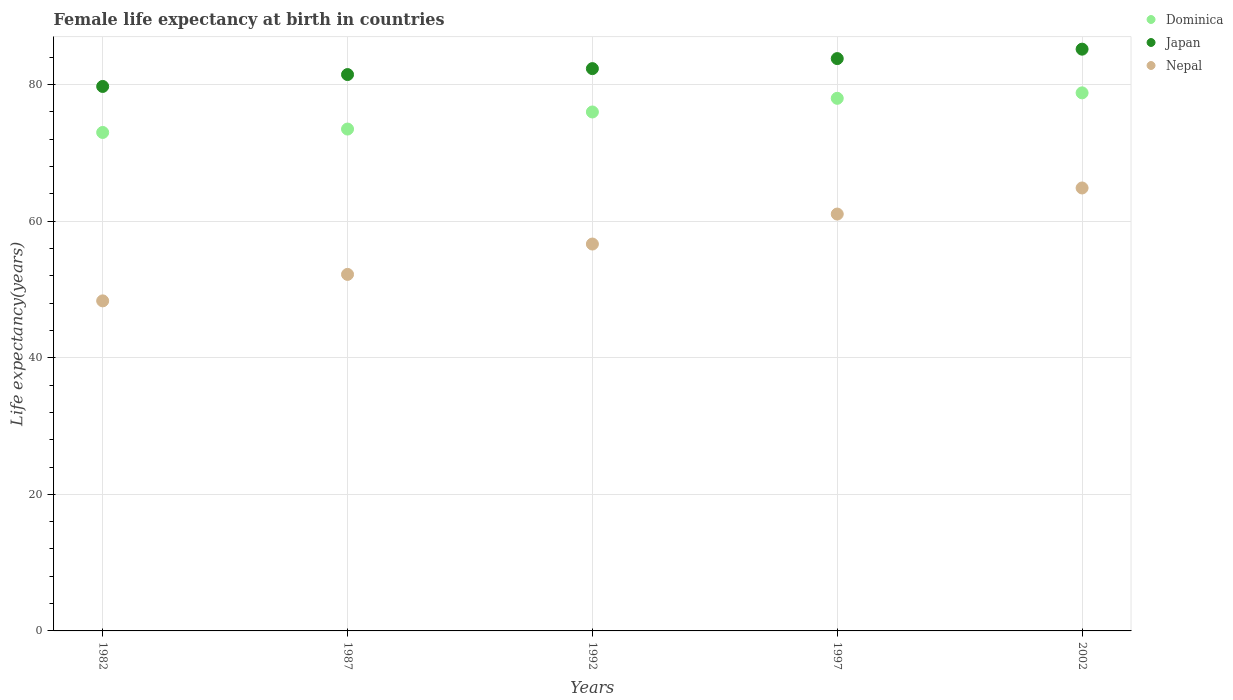Is the number of dotlines equal to the number of legend labels?
Offer a very short reply. Yes. What is the female life expectancy at birth in Japan in 1997?
Make the answer very short. 83.82. Across all years, what is the maximum female life expectancy at birth in Japan?
Your answer should be very brief. 85.2. Across all years, what is the minimum female life expectancy at birth in Nepal?
Make the answer very short. 48.34. What is the total female life expectancy at birth in Nepal in the graph?
Provide a short and direct response. 283.13. What is the difference between the female life expectancy at birth in Dominica in 1997 and that in 2002?
Provide a succinct answer. -0.8. What is the difference between the female life expectancy at birth in Nepal in 2002 and the female life expectancy at birth in Japan in 1982?
Offer a terse response. -14.87. What is the average female life expectancy at birth in Nepal per year?
Ensure brevity in your answer.  56.63. In the year 1992, what is the difference between the female life expectancy at birth in Nepal and female life expectancy at birth in Dominica?
Your answer should be very brief. -19.34. What is the ratio of the female life expectancy at birth in Nepal in 1982 to that in 1987?
Give a very brief answer. 0.93. Is the difference between the female life expectancy at birth in Nepal in 1987 and 1992 greater than the difference between the female life expectancy at birth in Dominica in 1987 and 1992?
Provide a short and direct response. No. What is the difference between the highest and the second highest female life expectancy at birth in Japan?
Offer a very short reply. 1.38. What is the difference between the highest and the lowest female life expectancy at birth in Nepal?
Your response must be concise. 16.53. Is it the case that in every year, the sum of the female life expectancy at birth in Dominica and female life expectancy at birth in Japan  is greater than the female life expectancy at birth in Nepal?
Your answer should be very brief. Yes. How many dotlines are there?
Keep it short and to the point. 3. What is the difference between two consecutive major ticks on the Y-axis?
Your response must be concise. 20. What is the title of the graph?
Offer a terse response. Female life expectancy at birth in countries. Does "Korea (Democratic)" appear as one of the legend labels in the graph?
Keep it short and to the point. No. What is the label or title of the X-axis?
Give a very brief answer. Years. What is the label or title of the Y-axis?
Offer a very short reply. Life expectancy(years). What is the Life expectancy(years) of Japan in 1982?
Your answer should be very brief. 79.74. What is the Life expectancy(years) of Nepal in 1982?
Provide a short and direct response. 48.34. What is the Life expectancy(years) in Dominica in 1987?
Give a very brief answer. 73.5. What is the Life expectancy(years) of Japan in 1987?
Your response must be concise. 81.48. What is the Life expectancy(years) of Nepal in 1987?
Your answer should be very brief. 52.22. What is the Life expectancy(years) in Dominica in 1992?
Offer a terse response. 76. What is the Life expectancy(years) in Japan in 1992?
Your answer should be compact. 82.35. What is the Life expectancy(years) in Nepal in 1992?
Keep it short and to the point. 56.66. What is the Life expectancy(years) in Japan in 1997?
Make the answer very short. 83.82. What is the Life expectancy(years) in Nepal in 1997?
Your answer should be compact. 61.05. What is the Life expectancy(years) of Dominica in 2002?
Offer a terse response. 78.8. What is the Life expectancy(years) of Japan in 2002?
Keep it short and to the point. 85.2. What is the Life expectancy(years) in Nepal in 2002?
Offer a terse response. 64.87. Across all years, what is the maximum Life expectancy(years) in Dominica?
Offer a very short reply. 78.8. Across all years, what is the maximum Life expectancy(years) in Japan?
Provide a succinct answer. 85.2. Across all years, what is the maximum Life expectancy(years) of Nepal?
Give a very brief answer. 64.87. Across all years, what is the minimum Life expectancy(years) in Japan?
Provide a succinct answer. 79.74. Across all years, what is the minimum Life expectancy(years) in Nepal?
Your response must be concise. 48.34. What is the total Life expectancy(years) of Dominica in the graph?
Provide a succinct answer. 379.3. What is the total Life expectancy(years) in Japan in the graph?
Ensure brevity in your answer.  412.59. What is the total Life expectancy(years) of Nepal in the graph?
Provide a short and direct response. 283.13. What is the difference between the Life expectancy(years) in Japan in 1982 and that in 1987?
Keep it short and to the point. -1.74. What is the difference between the Life expectancy(years) of Nepal in 1982 and that in 1987?
Keep it short and to the point. -3.88. What is the difference between the Life expectancy(years) of Dominica in 1982 and that in 1992?
Keep it short and to the point. -3. What is the difference between the Life expectancy(years) of Japan in 1982 and that in 1992?
Your response must be concise. -2.61. What is the difference between the Life expectancy(years) in Nepal in 1982 and that in 1992?
Make the answer very short. -8.32. What is the difference between the Life expectancy(years) in Dominica in 1982 and that in 1997?
Provide a succinct answer. -5. What is the difference between the Life expectancy(years) of Japan in 1982 and that in 1997?
Your answer should be very brief. -4.08. What is the difference between the Life expectancy(years) in Nepal in 1982 and that in 1997?
Offer a very short reply. -12.71. What is the difference between the Life expectancy(years) in Japan in 1982 and that in 2002?
Offer a terse response. -5.46. What is the difference between the Life expectancy(years) in Nepal in 1982 and that in 2002?
Your response must be concise. -16.54. What is the difference between the Life expectancy(years) in Dominica in 1987 and that in 1992?
Make the answer very short. -2.5. What is the difference between the Life expectancy(years) of Japan in 1987 and that in 1992?
Offer a very short reply. -0.87. What is the difference between the Life expectancy(years) in Nepal in 1987 and that in 1992?
Your answer should be very brief. -4.45. What is the difference between the Life expectancy(years) in Japan in 1987 and that in 1997?
Provide a short and direct response. -2.34. What is the difference between the Life expectancy(years) in Nepal in 1987 and that in 1997?
Offer a very short reply. -8.84. What is the difference between the Life expectancy(years) in Japan in 1987 and that in 2002?
Provide a short and direct response. -3.72. What is the difference between the Life expectancy(years) in Nepal in 1987 and that in 2002?
Provide a succinct answer. -12.66. What is the difference between the Life expectancy(years) in Dominica in 1992 and that in 1997?
Provide a succinct answer. -2. What is the difference between the Life expectancy(years) of Japan in 1992 and that in 1997?
Provide a short and direct response. -1.47. What is the difference between the Life expectancy(years) of Nepal in 1992 and that in 1997?
Keep it short and to the point. -4.39. What is the difference between the Life expectancy(years) of Japan in 1992 and that in 2002?
Keep it short and to the point. -2.85. What is the difference between the Life expectancy(years) of Nepal in 1992 and that in 2002?
Your answer should be very brief. -8.21. What is the difference between the Life expectancy(years) in Dominica in 1997 and that in 2002?
Offer a very short reply. -0.8. What is the difference between the Life expectancy(years) of Japan in 1997 and that in 2002?
Ensure brevity in your answer.  -1.38. What is the difference between the Life expectancy(years) of Nepal in 1997 and that in 2002?
Keep it short and to the point. -3.82. What is the difference between the Life expectancy(years) in Dominica in 1982 and the Life expectancy(years) in Japan in 1987?
Your answer should be compact. -8.48. What is the difference between the Life expectancy(years) in Dominica in 1982 and the Life expectancy(years) in Nepal in 1987?
Offer a very short reply. 20.79. What is the difference between the Life expectancy(years) in Japan in 1982 and the Life expectancy(years) in Nepal in 1987?
Your response must be concise. 27.52. What is the difference between the Life expectancy(years) of Dominica in 1982 and the Life expectancy(years) of Japan in 1992?
Provide a succinct answer. -9.35. What is the difference between the Life expectancy(years) of Dominica in 1982 and the Life expectancy(years) of Nepal in 1992?
Ensure brevity in your answer.  16.34. What is the difference between the Life expectancy(years) of Japan in 1982 and the Life expectancy(years) of Nepal in 1992?
Offer a very short reply. 23.08. What is the difference between the Life expectancy(years) of Dominica in 1982 and the Life expectancy(years) of Japan in 1997?
Offer a very short reply. -10.82. What is the difference between the Life expectancy(years) of Dominica in 1982 and the Life expectancy(years) of Nepal in 1997?
Keep it short and to the point. 11.95. What is the difference between the Life expectancy(years) of Japan in 1982 and the Life expectancy(years) of Nepal in 1997?
Offer a very short reply. 18.69. What is the difference between the Life expectancy(years) of Dominica in 1982 and the Life expectancy(years) of Nepal in 2002?
Keep it short and to the point. 8.13. What is the difference between the Life expectancy(years) in Japan in 1982 and the Life expectancy(years) in Nepal in 2002?
Your answer should be compact. 14.87. What is the difference between the Life expectancy(years) in Dominica in 1987 and the Life expectancy(years) in Japan in 1992?
Your answer should be very brief. -8.85. What is the difference between the Life expectancy(years) in Dominica in 1987 and the Life expectancy(years) in Nepal in 1992?
Offer a terse response. 16.84. What is the difference between the Life expectancy(years) of Japan in 1987 and the Life expectancy(years) of Nepal in 1992?
Offer a very short reply. 24.82. What is the difference between the Life expectancy(years) of Dominica in 1987 and the Life expectancy(years) of Japan in 1997?
Give a very brief answer. -10.32. What is the difference between the Life expectancy(years) in Dominica in 1987 and the Life expectancy(years) in Nepal in 1997?
Your answer should be very brief. 12.45. What is the difference between the Life expectancy(years) in Japan in 1987 and the Life expectancy(years) in Nepal in 1997?
Offer a very short reply. 20.43. What is the difference between the Life expectancy(years) of Dominica in 1987 and the Life expectancy(years) of Nepal in 2002?
Offer a very short reply. 8.63. What is the difference between the Life expectancy(years) in Japan in 1987 and the Life expectancy(years) in Nepal in 2002?
Keep it short and to the point. 16.61. What is the difference between the Life expectancy(years) of Dominica in 1992 and the Life expectancy(years) of Japan in 1997?
Provide a short and direct response. -7.82. What is the difference between the Life expectancy(years) of Dominica in 1992 and the Life expectancy(years) of Nepal in 1997?
Provide a succinct answer. 14.95. What is the difference between the Life expectancy(years) of Japan in 1992 and the Life expectancy(years) of Nepal in 1997?
Your answer should be very brief. 21.3. What is the difference between the Life expectancy(years) of Dominica in 1992 and the Life expectancy(years) of Nepal in 2002?
Your answer should be compact. 11.13. What is the difference between the Life expectancy(years) in Japan in 1992 and the Life expectancy(years) in Nepal in 2002?
Your response must be concise. 17.48. What is the difference between the Life expectancy(years) in Dominica in 1997 and the Life expectancy(years) in Japan in 2002?
Give a very brief answer. -7.2. What is the difference between the Life expectancy(years) of Dominica in 1997 and the Life expectancy(years) of Nepal in 2002?
Make the answer very short. 13.13. What is the difference between the Life expectancy(years) in Japan in 1997 and the Life expectancy(years) in Nepal in 2002?
Provide a succinct answer. 18.95. What is the average Life expectancy(years) in Dominica per year?
Provide a succinct answer. 75.86. What is the average Life expectancy(years) of Japan per year?
Your response must be concise. 82.52. What is the average Life expectancy(years) in Nepal per year?
Your answer should be very brief. 56.63. In the year 1982, what is the difference between the Life expectancy(years) of Dominica and Life expectancy(years) of Japan?
Give a very brief answer. -6.74. In the year 1982, what is the difference between the Life expectancy(years) in Dominica and Life expectancy(years) in Nepal?
Provide a succinct answer. 24.66. In the year 1982, what is the difference between the Life expectancy(years) of Japan and Life expectancy(years) of Nepal?
Give a very brief answer. 31.4. In the year 1987, what is the difference between the Life expectancy(years) of Dominica and Life expectancy(years) of Japan?
Provide a short and direct response. -7.98. In the year 1987, what is the difference between the Life expectancy(years) of Dominica and Life expectancy(years) of Nepal?
Make the answer very short. 21.29. In the year 1987, what is the difference between the Life expectancy(years) of Japan and Life expectancy(years) of Nepal?
Your answer should be very brief. 29.27. In the year 1992, what is the difference between the Life expectancy(years) of Dominica and Life expectancy(years) of Japan?
Your response must be concise. -6.35. In the year 1992, what is the difference between the Life expectancy(years) of Dominica and Life expectancy(years) of Nepal?
Your answer should be compact. 19.34. In the year 1992, what is the difference between the Life expectancy(years) of Japan and Life expectancy(years) of Nepal?
Your answer should be compact. 25.69. In the year 1997, what is the difference between the Life expectancy(years) of Dominica and Life expectancy(years) of Japan?
Provide a succinct answer. -5.82. In the year 1997, what is the difference between the Life expectancy(years) of Dominica and Life expectancy(years) of Nepal?
Keep it short and to the point. 16.95. In the year 1997, what is the difference between the Life expectancy(years) of Japan and Life expectancy(years) of Nepal?
Make the answer very short. 22.77. In the year 2002, what is the difference between the Life expectancy(years) of Dominica and Life expectancy(years) of Nepal?
Your response must be concise. 13.93. In the year 2002, what is the difference between the Life expectancy(years) of Japan and Life expectancy(years) of Nepal?
Your answer should be very brief. 20.33. What is the ratio of the Life expectancy(years) in Dominica in 1982 to that in 1987?
Your answer should be very brief. 0.99. What is the ratio of the Life expectancy(years) of Japan in 1982 to that in 1987?
Keep it short and to the point. 0.98. What is the ratio of the Life expectancy(years) in Nepal in 1982 to that in 1987?
Your answer should be compact. 0.93. What is the ratio of the Life expectancy(years) in Dominica in 1982 to that in 1992?
Your response must be concise. 0.96. What is the ratio of the Life expectancy(years) in Japan in 1982 to that in 1992?
Keep it short and to the point. 0.97. What is the ratio of the Life expectancy(years) in Nepal in 1982 to that in 1992?
Give a very brief answer. 0.85. What is the ratio of the Life expectancy(years) in Dominica in 1982 to that in 1997?
Your response must be concise. 0.94. What is the ratio of the Life expectancy(years) of Japan in 1982 to that in 1997?
Ensure brevity in your answer.  0.95. What is the ratio of the Life expectancy(years) in Nepal in 1982 to that in 1997?
Provide a short and direct response. 0.79. What is the ratio of the Life expectancy(years) in Dominica in 1982 to that in 2002?
Ensure brevity in your answer.  0.93. What is the ratio of the Life expectancy(years) in Japan in 1982 to that in 2002?
Make the answer very short. 0.94. What is the ratio of the Life expectancy(years) of Nepal in 1982 to that in 2002?
Your answer should be very brief. 0.75. What is the ratio of the Life expectancy(years) of Dominica in 1987 to that in 1992?
Offer a terse response. 0.97. What is the ratio of the Life expectancy(years) of Japan in 1987 to that in 1992?
Offer a very short reply. 0.99. What is the ratio of the Life expectancy(years) of Nepal in 1987 to that in 1992?
Your response must be concise. 0.92. What is the ratio of the Life expectancy(years) of Dominica in 1987 to that in 1997?
Your response must be concise. 0.94. What is the ratio of the Life expectancy(years) in Japan in 1987 to that in 1997?
Offer a very short reply. 0.97. What is the ratio of the Life expectancy(years) in Nepal in 1987 to that in 1997?
Your answer should be compact. 0.86. What is the ratio of the Life expectancy(years) in Dominica in 1987 to that in 2002?
Your answer should be very brief. 0.93. What is the ratio of the Life expectancy(years) of Japan in 1987 to that in 2002?
Offer a terse response. 0.96. What is the ratio of the Life expectancy(years) in Nepal in 1987 to that in 2002?
Provide a succinct answer. 0.8. What is the ratio of the Life expectancy(years) of Dominica in 1992 to that in 1997?
Your answer should be very brief. 0.97. What is the ratio of the Life expectancy(years) in Japan in 1992 to that in 1997?
Give a very brief answer. 0.98. What is the ratio of the Life expectancy(years) in Nepal in 1992 to that in 1997?
Offer a very short reply. 0.93. What is the ratio of the Life expectancy(years) of Dominica in 1992 to that in 2002?
Provide a short and direct response. 0.96. What is the ratio of the Life expectancy(years) of Japan in 1992 to that in 2002?
Provide a short and direct response. 0.97. What is the ratio of the Life expectancy(years) of Nepal in 1992 to that in 2002?
Offer a terse response. 0.87. What is the ratio of the Life expectancy(years) of Japan in 1997 to that in 2002?
Provide a succinct answer. 0.98. What is the ratio of the Life expectancy(years) of Nepal in 1997 to that in 2002?
Make the answer very short. 0.94. What is the difference between the highest and the second highest Life expectancy(years) of Dominica?
Provide a succinct answer. 0.8. What is the difference between the highest and the second highest Life expectancy(years) in Japan?
Your response must be concise. 1.38. What is the difference between the highest and the second highest Life expectancy(years) in Nepal?
Offer a very short reply. 3.82. What is the difference between the highest and the lowest Life expectancy(years) of Dominica?
Ensure brevity in your answer.  5.8. What is the difference between the highest and the lowest Life expectancy(years) in Japan?
Give a very brief answer. 5.46. What is the difference between the highest and the lowest Life expectancy(years) in Nepal?
Keep it short and to the point. 16.54. 